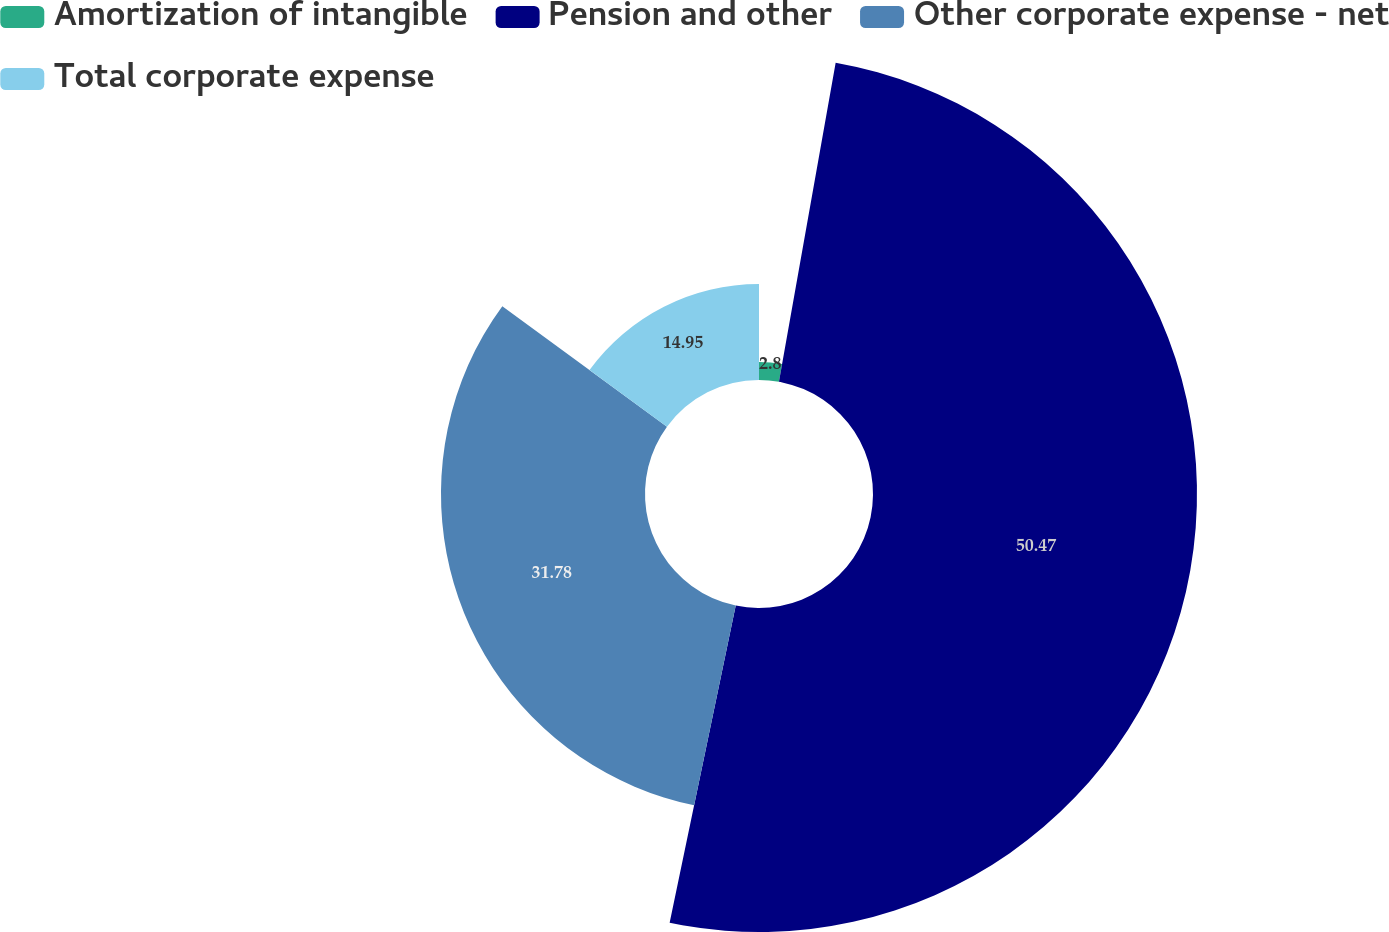Convert chart. <chart><loc_0><loc_0><loc_500><loc_500><pie_chart><fcel>Amortization of intangible<fcel>Pension and other<fcel>Other corporate expense - net<fcel>Total corporate expense<nl><fcel>2.8%<fcel>50.47%<fcel>31.78%<fcel>14.95%<nl></chart> 